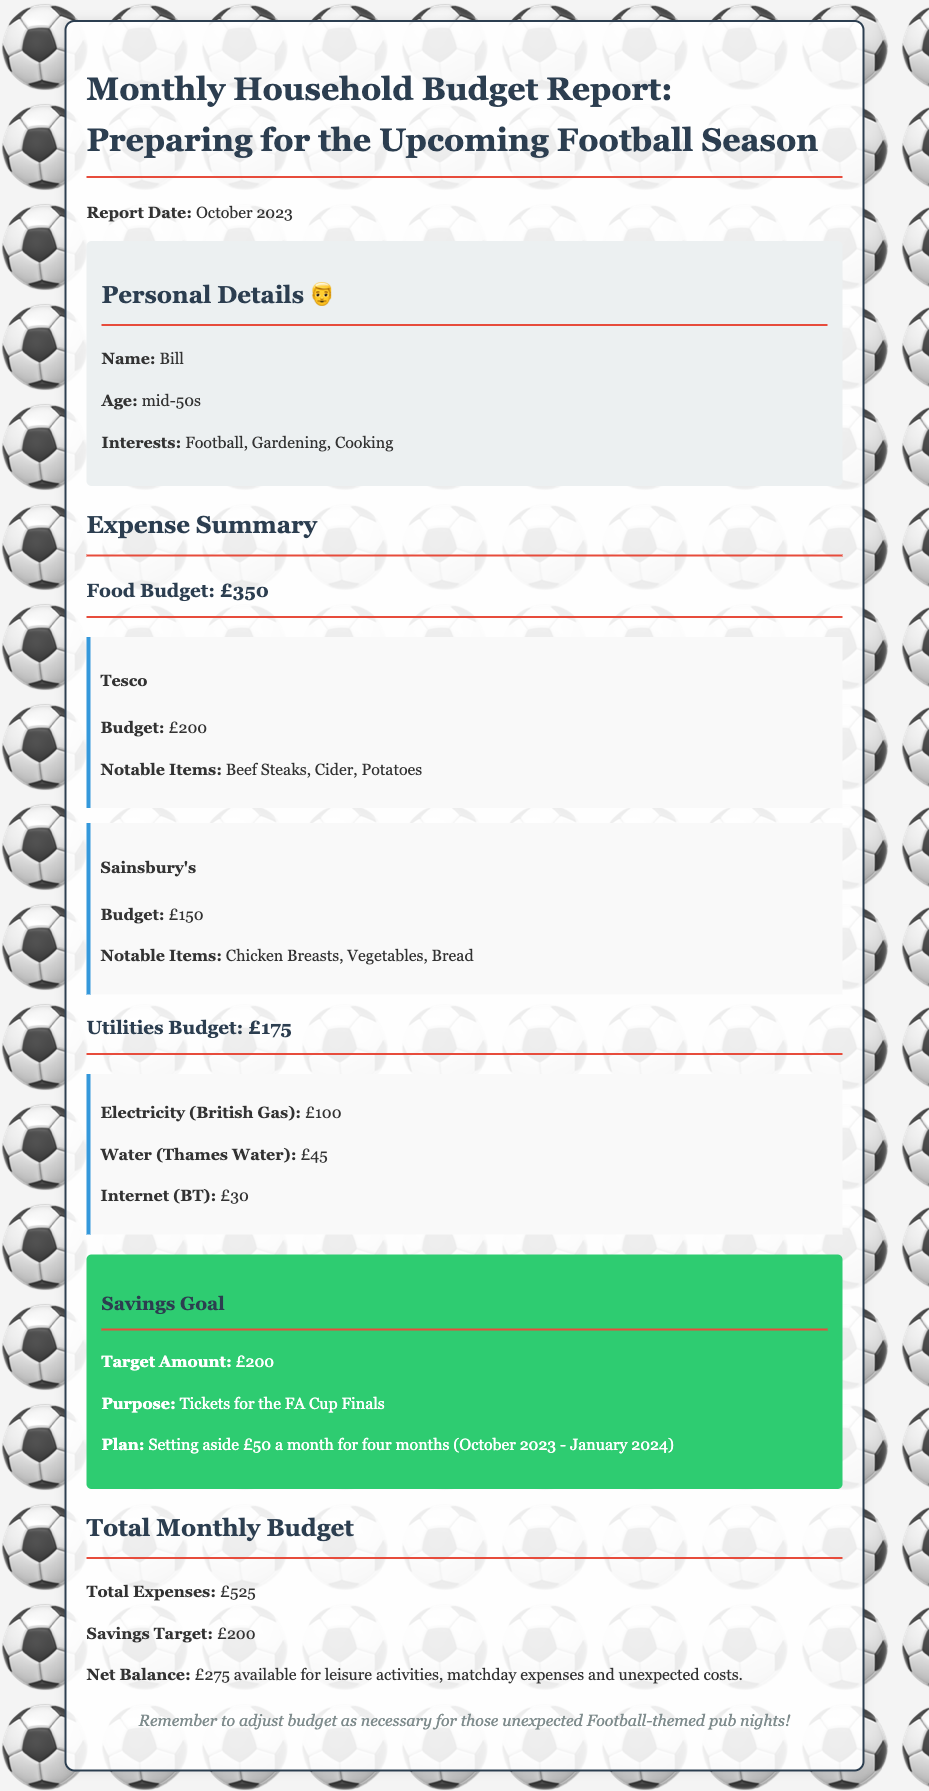What is the food budget? The food budget is listed in the expense summary section of the document, which states £350.
Answer: £350 What are notable items from Tesco? The notable items listed for Tesco under the food budget are Beef Steaks, Cider, and Potatoes.
Answer: Beef Steaks, Cider, Potatoes What is the total monthly budget? The total monthly budget is mentioned towards the end of the document and includes total expenses and savings target.
Answer: £525 What is the savings target? The savings target is specified in the savings goal section of the document, as £200.
Answer: £200 How much will be set aside each month for savings? The document states that £50 will be set aside each month for savings towards the target amount.
Answer: £50 What is the purpose of the savings goal? The purpose of the savings goal is outlined in the savings goal section of the document as for Tickets for the FA Cup Finals.
Answer: Tickets for the FA Cup Finals What is the net balance available for leisure activities? The net balance is calculated from total expenses and savings target, allowing for discretionary spending stated in the budget report.
Answer: £275 What is included in the electricity budget? The electricity budget is specified in the utilities budget section which shows how much is allocated for electricity.
Answer: £100 How many months will the savings goal span? The plan for savings in the document indicates that the goal will span from October 2023 to January 2024, which is four months.
Answer: Four months 